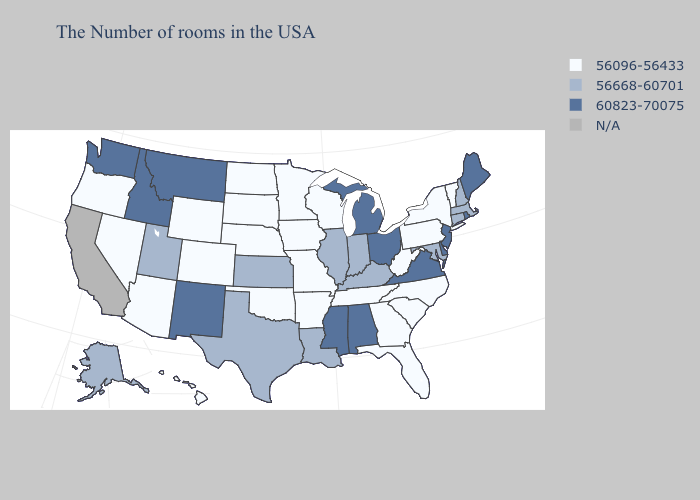Does the map have missing data?
Be succinct. Yes. Name the states that have a value in the range N/A?
Write a very short answer. California. What is the lowest value in the USA?
Answer briefly. 56096-56433. Among the states that border Georgia , which have the lowest value?
Quick response, please. North Carolina, South Carolina, Florida, Tennessee. Name the states that have a value in the range 60823-70075?
Quick response, please. Maine, Rhode Island, New Jersey, Delaware, Virginia, Ohio, Michigan, Alabama, Mississippi, New Mexico, Montana, Idaho, Washington. Name the states that have a value in the range N/A?
Give a very brief answer. California. Does New York have the lowest value in the Northeast?
Concise answer only. Yes. Does Utah have the lowest value in the USA?
Quick response, please. No. What is the highest value in the Northeast ?
Be succinct. 60823-70075. Name the states that have a value in the range 60823-70075?
Give a very brief answer. Maine, Rhode Island, New Jersey, Delaware, Virginia, Ohio, Michigan, Alabama, Mississippi, New Mexico, Montana, Idaho, Washington. Name the states that have a value in the range 60823-70075?
Keep it brief. Maine, Rhode Island, New Jersey, Delaware, Virginia, Ohio, Michigan, Alabama, Mississippi, New Mexico, Montana, Idaho, Washington. Name the states that have a value in the range N/A?
Write a very short answer. California. How many symbols are there in the legend?
Short answer required. 4. 